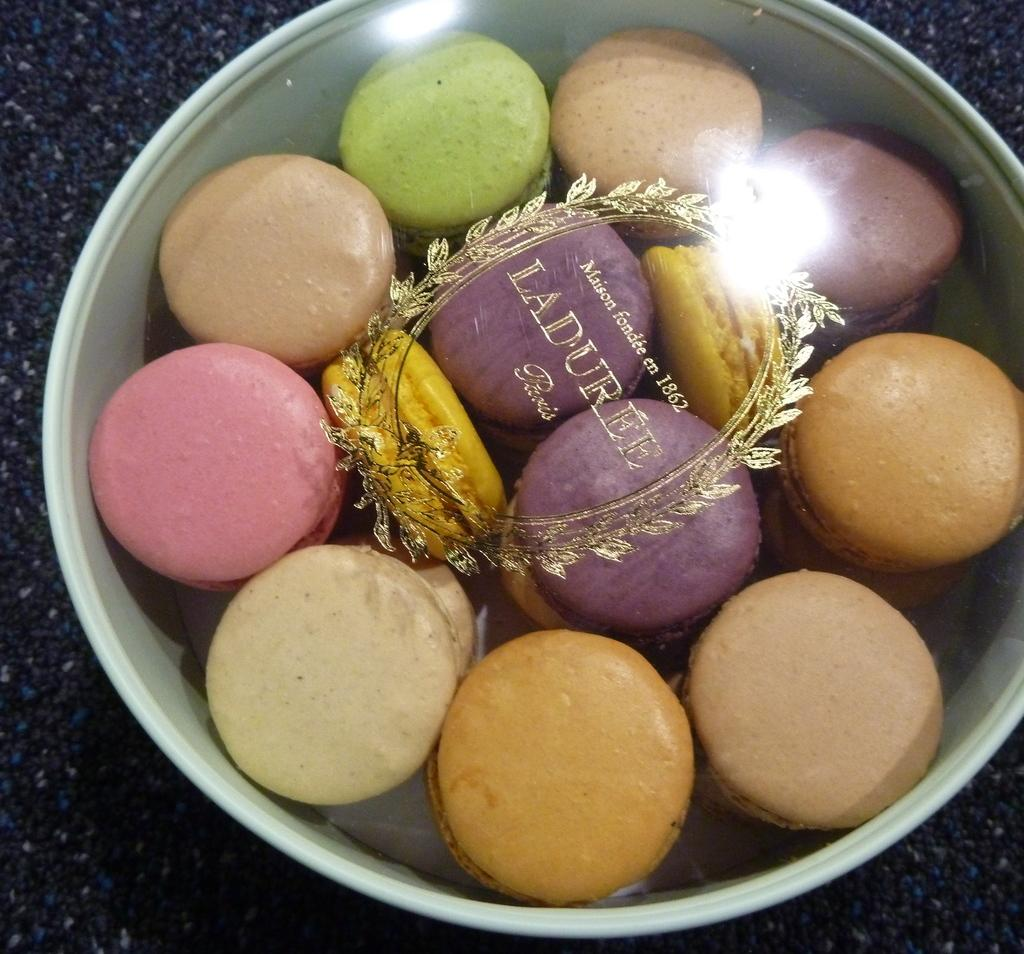What type of food is in the container in the image? There are macarons in the container. What is covering the container in the image? The container is covered with a glass object. What can be seen on the glass object? There is a design and text on the glass object. What is visible in the background of the image? The surface is visible in the image. How many friends are sitting on the honey in the image? There is no honey or friends present in the image. 